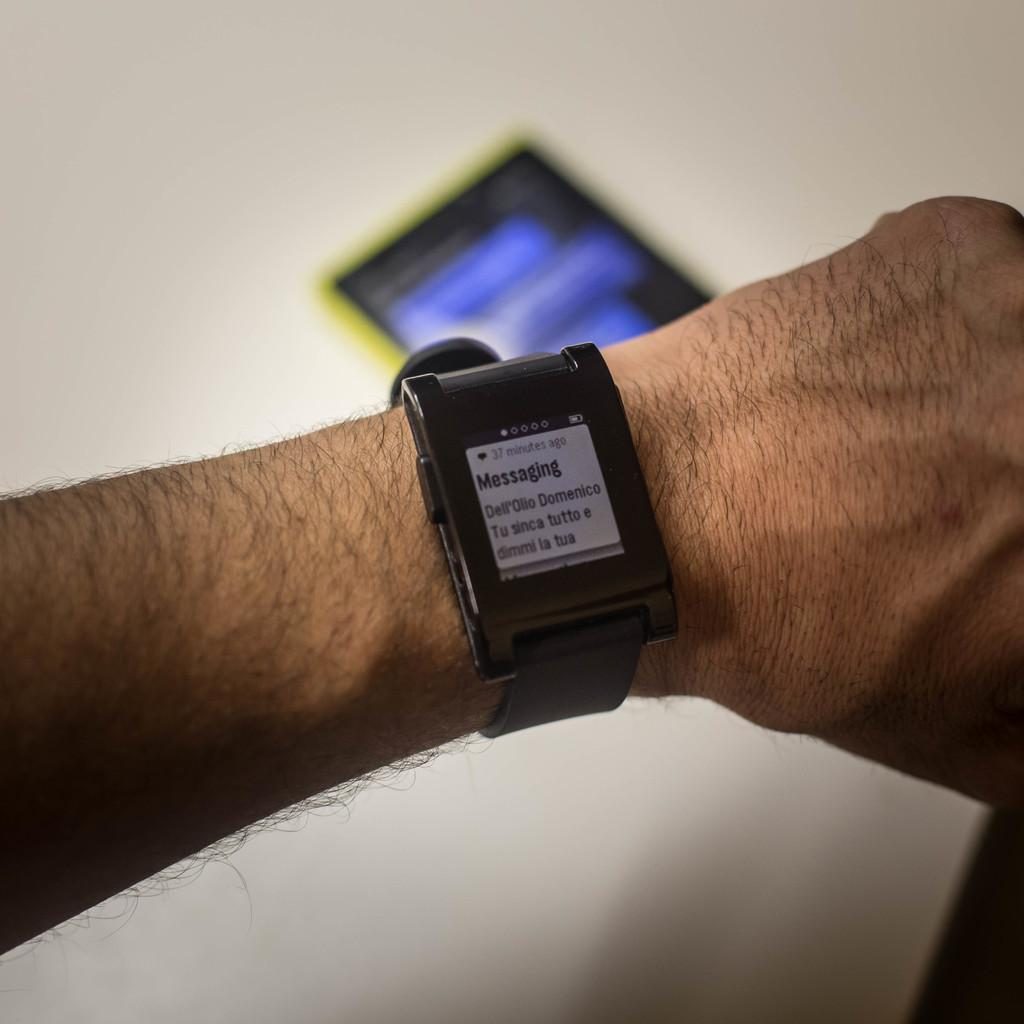<image>
Describe the image concisely. A man is displaying a messaging app on his watch. 